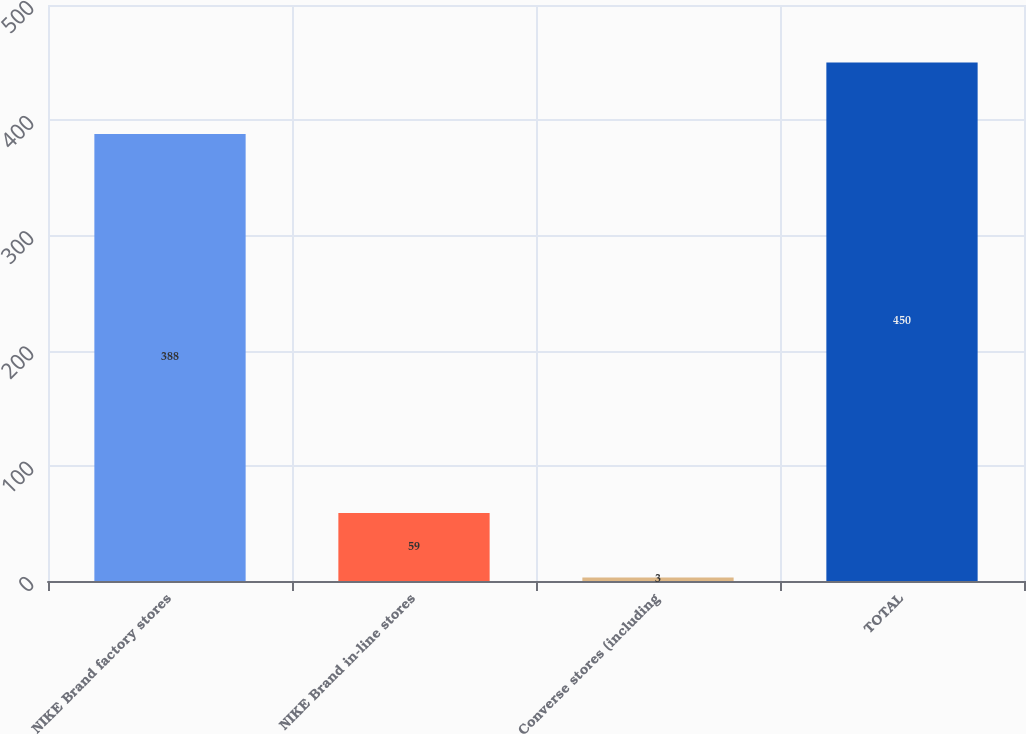Convert chart to OTSL. <chart><loc_0><loc_0><loc_500><loc_500><bar_chart><fcel>NIKE Brand factory stores<fcel>NIKE Brand in-line stores<fcel>Converse stores (including<fcel>TOTAL<nl><fcel>388<fcel>59<fcel>3<fcel>450<nl></chart> 